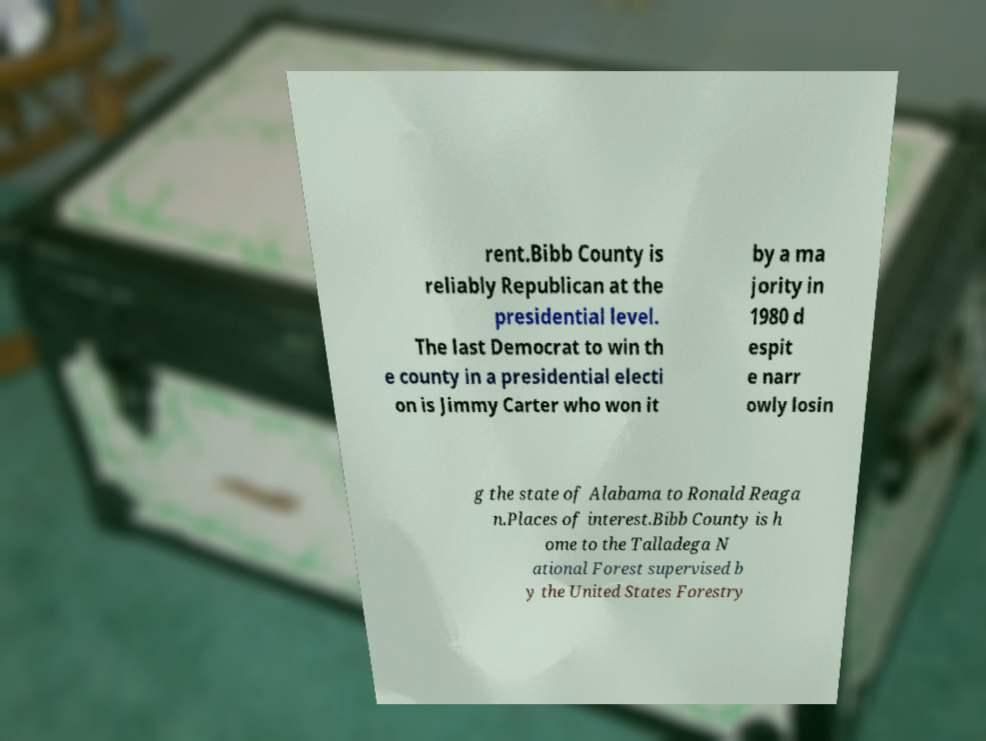I need the written content from this picture converted into text. Can you do that? rent.Bibb County is reliably Republican at the presidential level. The last Democrat to win th e county in a presidential electi on is Jimmy Carter who won it by a ma jority in 1980 d espit e narr owly losin g the state of Alabama to Ronald Reaga n.Places of interest.Bibb County is h ome to the Talladega N ational Forest supervised b y the United States Forestry 